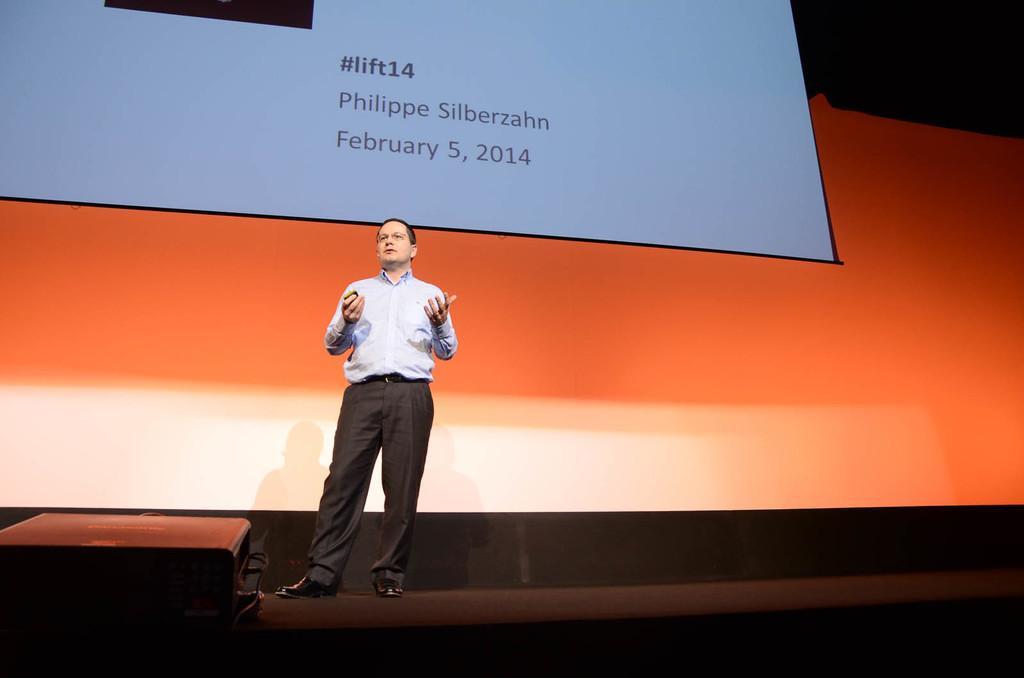Describe this image in one or two sentences. In this image there is a person standing. In front of him there is some object. Behind him there is a screen with some text and numbers on it. 